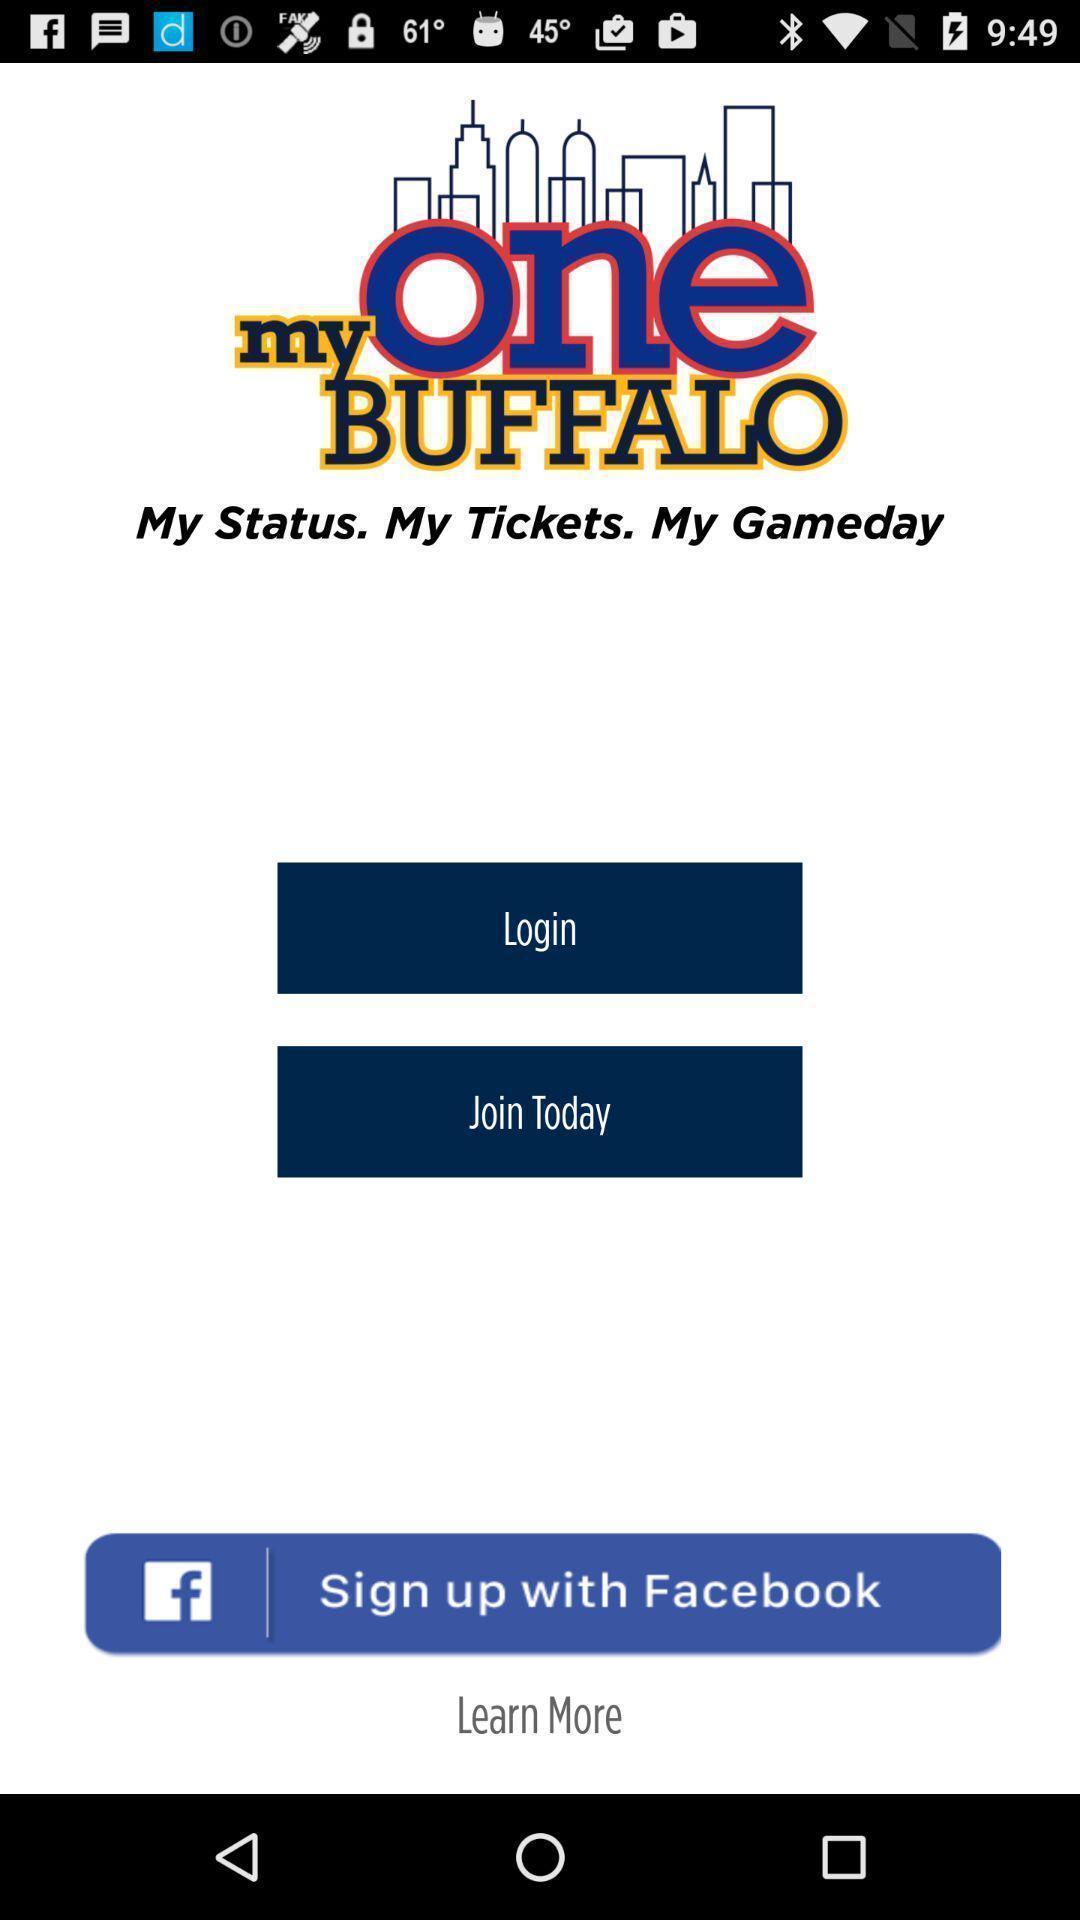Tell me about the visual elements in this screen capture. Welcome page. 